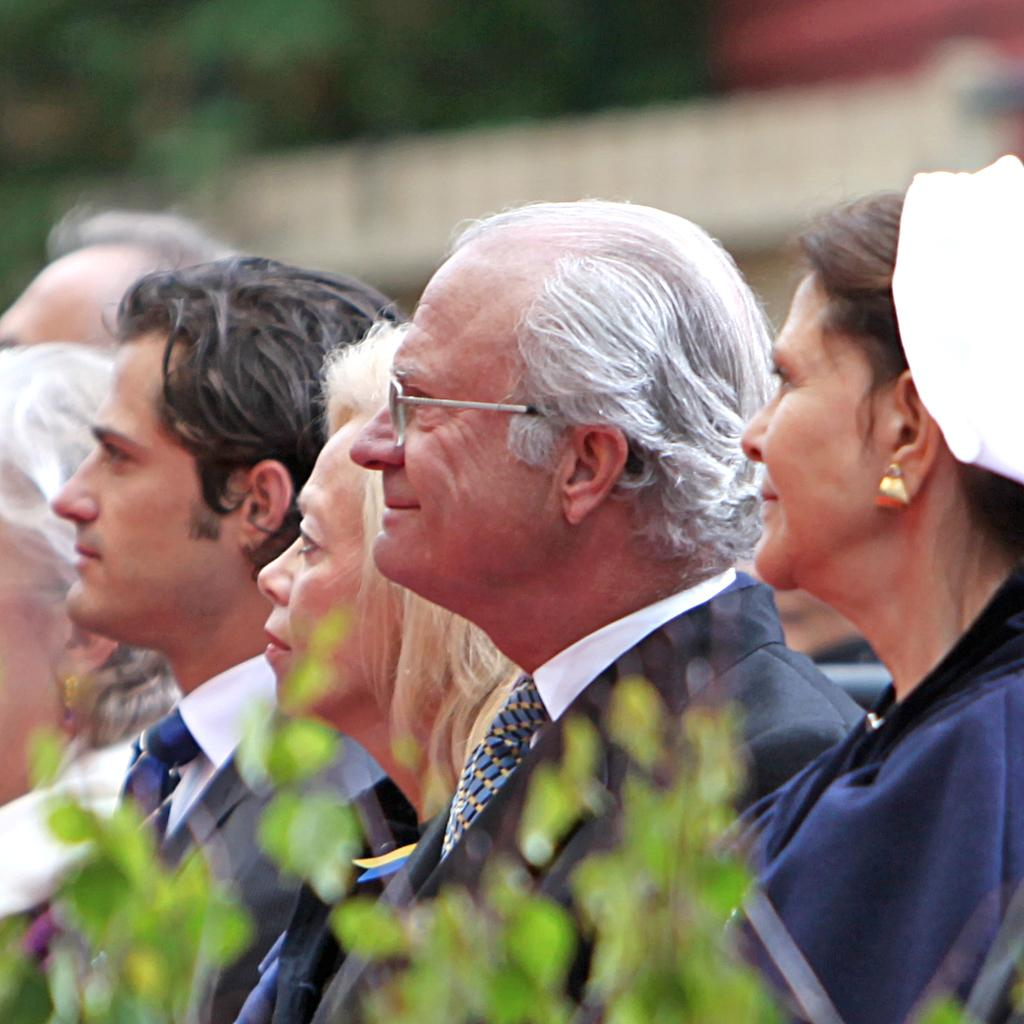Who or what can be seen in the image? There are people in the image. What are the people doing or looking at? The people are looking to the left side of the image. Can you describe the background of the image? The background of the image is blurred. What page of the book are the people reading in the image? There is no book present in the image, so it is not possible to determine which page they might be reading. 